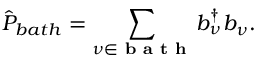<formula> <loc_0><loc_0><loc_500><loc_500>\hat { P } _ { b a t h } = \sum _ { \nu \in b a t h } b _ { \nu } ^ { \dagger } b _ { \nu } .</formula> 